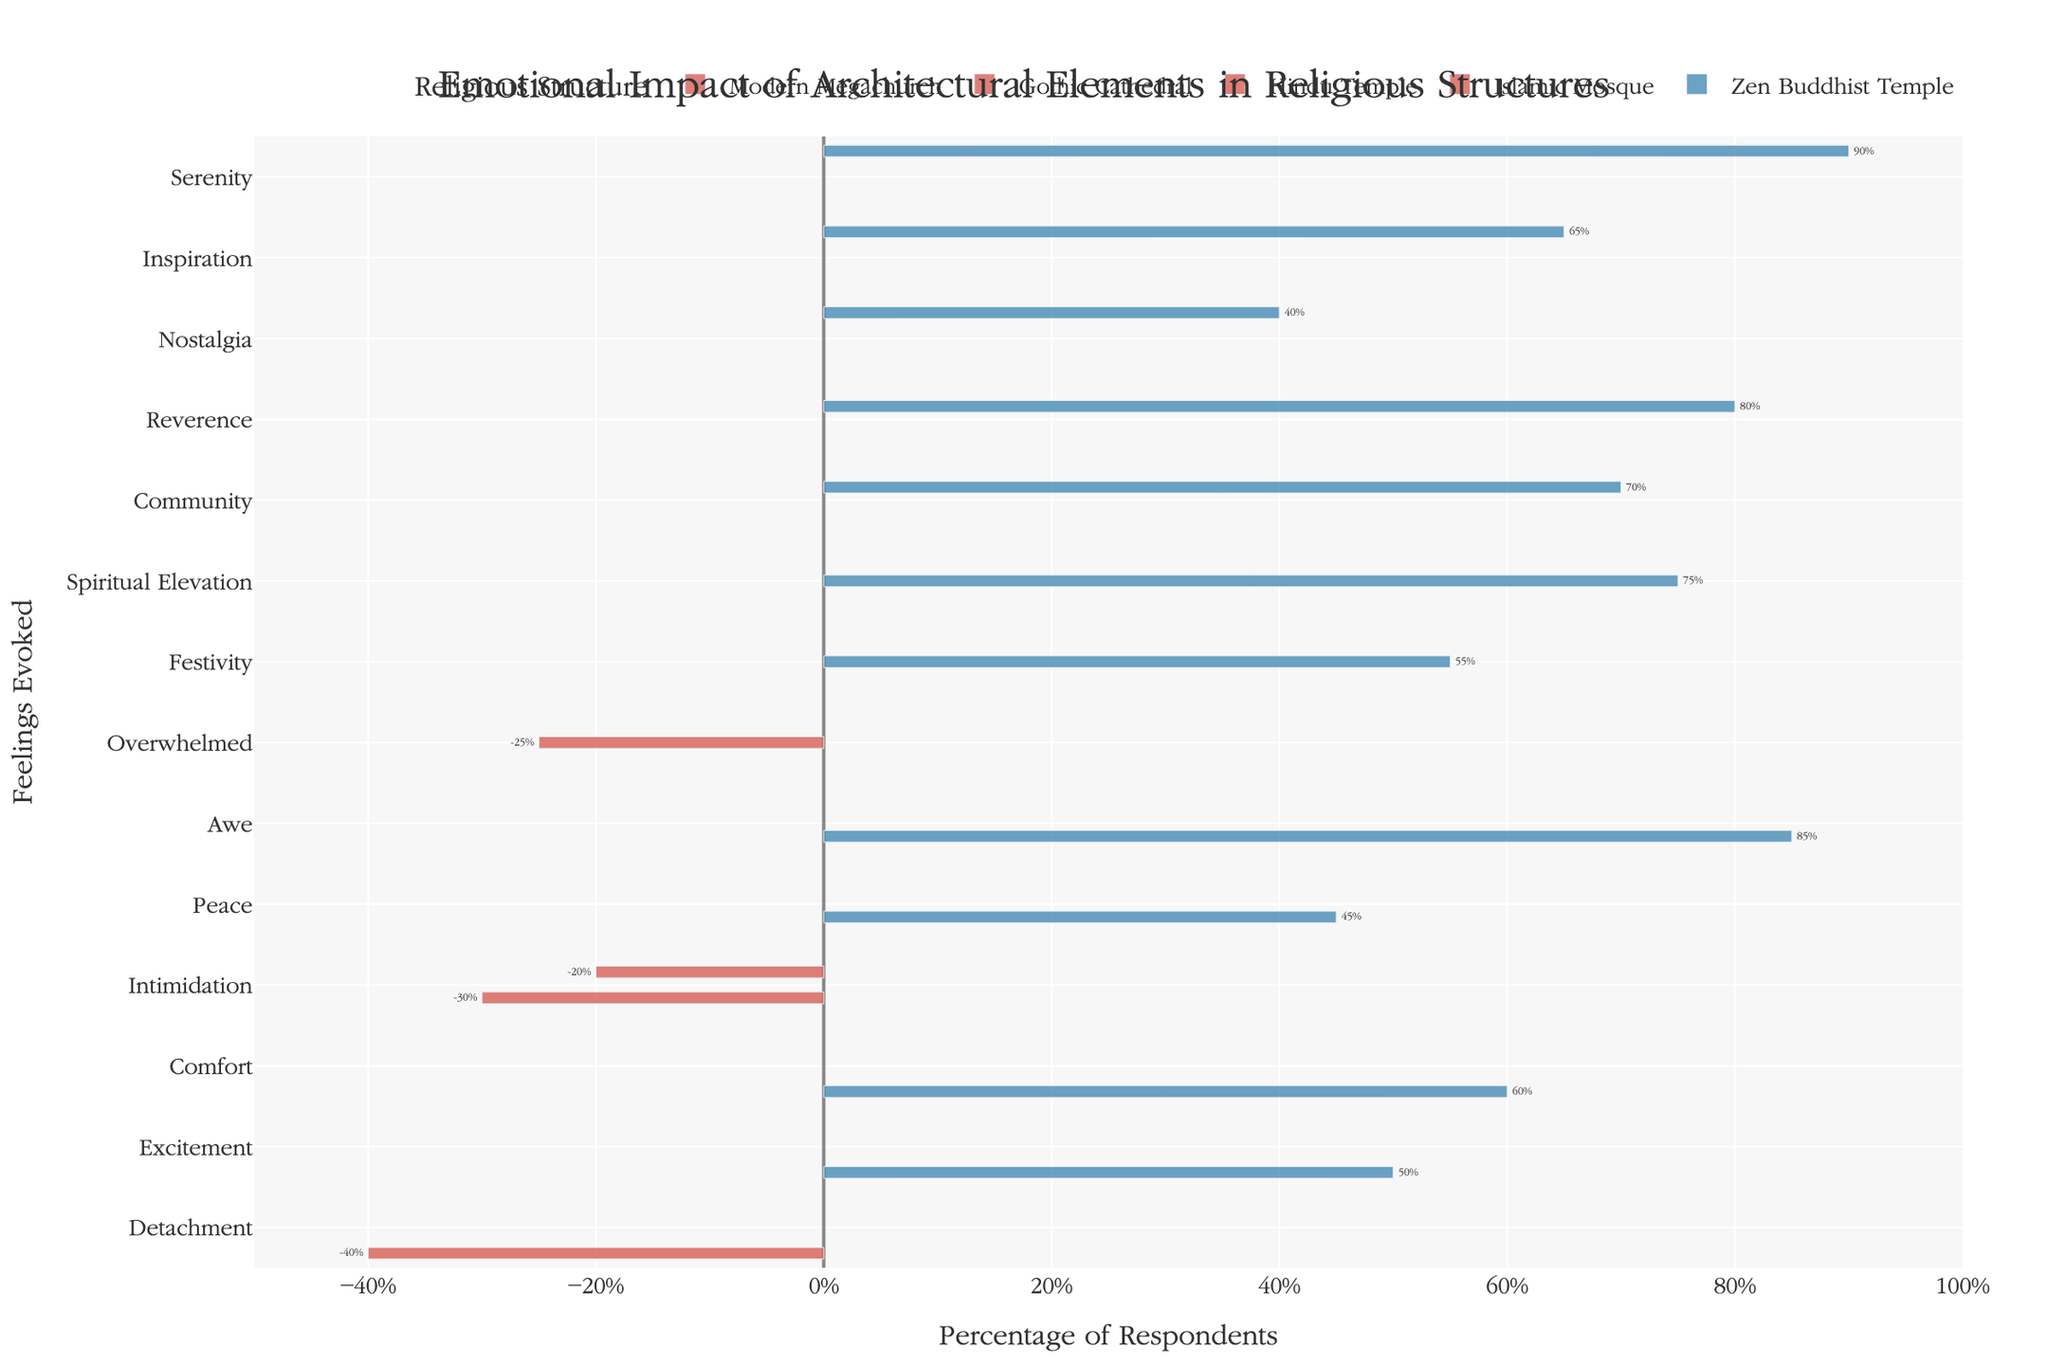What's the feeling with the highest percentage for Zen Buddhist Temple? The tallest bar for Zen Buddhist Temple has a value of 90%, which represents Serenity.
Answer: Serenity Which structure has the most negative feeling and what is it? The bar stretching the farthest to the left represents the most negative feeling, which is Detachment for Modern Megachurch at -40%.
Answer: Modern Megachurch, Detachment How does the feeling of Intimidation compare between Gothic Cathedral and Islamic Mosque? For Gothic Cathedral, Intimidation is at -30%. For Islamic Mosque, Intimidation is at -20%. Gothic Cathedral has a more negative impact for Intimidation compared to the Islamic Mosque.
Answer: Gothic Cathedral is more intimidating Which two structures have the highest positive emotional impact and what are they? The feelings with the highest positive percentages are Serenity for Zen Buddhist Temple at 90%, and Awe for Gothic Cathedral at 85%.
Answer: Zen Buddhist Temple, Gothic Cathedral What is the average positive percentage of the feelings evoked by Islamic Mosque? Positive percentages for Islamic Mosque are Reverence (80%), Community (70%). The average is (80 + 70) / 2 = 75%.
Answer: 75% Which structure evokes both the highest sense of peace and the highest sense of intimidation? Gothic Cathedral shows the highest positive feeling for Peace (45%) and the highest negative feeling for Intimidation (-30%).
Answer: Gothic Cathedral Which feeling does Hindu Temple evoke more, Festivity or Overwhelmed? The bar for Festivity is at 55% while the bar for Overwhelmed is at -25%. Festivity is higher.
Answer: Festivity Compare the feeling of Comfort between Modern Megachurch and Gothic Cathedral. Which one has a higher percentage? Modern Megachurch has Comfort at 60%, and Gothic Cathedral does not have Comfort listed. Therefore, Modern Megachurch has the higher percentage.
Answer: Modern Megachurch What is the total negative impact percentage for Modern Megachurch? The only negative feeling for Modern Megachurch is Detachment at -40%.
Answer: -40% How many different feelings have positive impacts greater than 50% from all structures? The feelings with positive impacts greater than 50% are Awe (85%), Peace (45%), Serenity (90%), Inspiration (65%), Community (70%), Spiritual Elevation (75%), Festivity (55%), Comfort (60%). Counting these unique positive feelings results in six: Awe, Peace, Serenity, Inspiration, Community, Spiritual Elevation, Festivity, and Comfort.
Answer: 8 